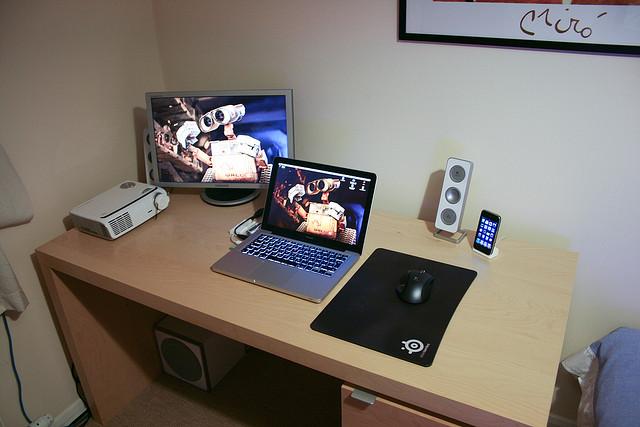What robot is shown on the monitor?
Write a very short answer. Wall-e. What brand is the mouse pad?
Concise answer only. Hp. How many monitors are on the desk?
Write a very short answer. 2. Is this a clean room?
Be succinct. Yes. What color is the mousepad?
Be succinct. Black. How many computer monitors are on the desk?
Answer briefly. 2. What room is this in?
Keep it brief. Bedroom. What type of OS does the big computer have?
Give a very brief answer. Windows. 